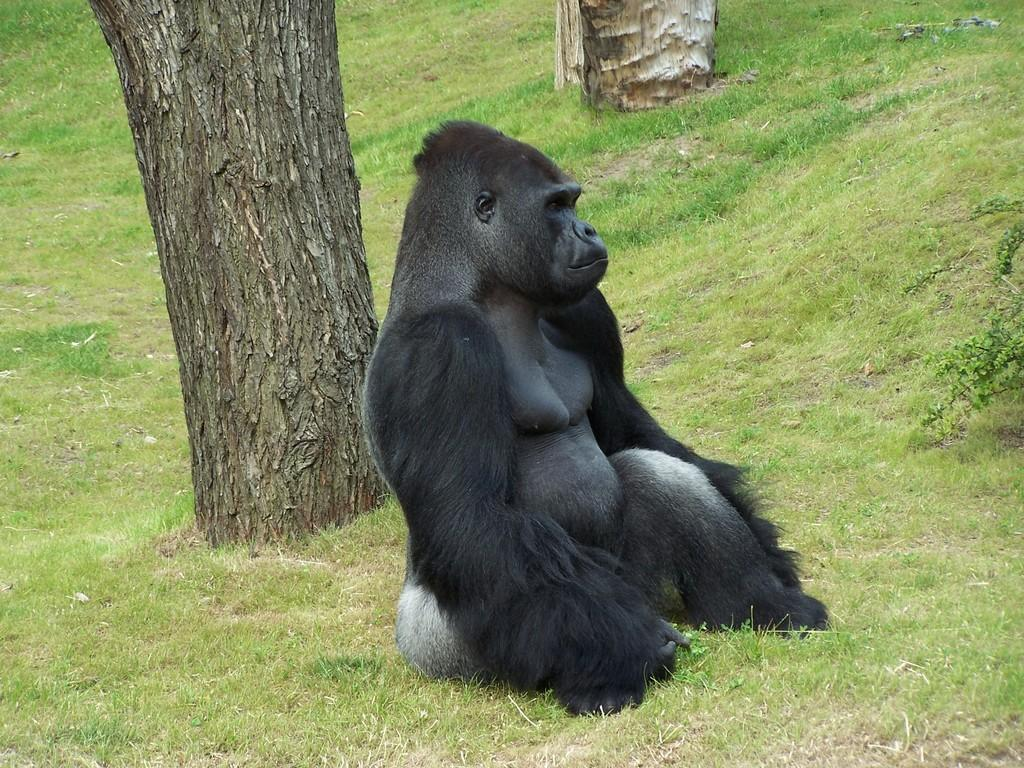What animal is the main subject of the image? There is a gorilla in the image. Where is the gorilla located? The gorilla is sitting on a grassy land. What can be seen on the left side of the image? There is a bark of a tree on the left side of the image. How many ducks are swimming in the water near the gorilla in the image? There are no ducks or water present in the image; it features a gorilla sitting on a grassy land. What type of zebra can be seen grazing on the grass near the gorilla in the image? There is no zebra present in the image; it features a gorilla sitting on a grassy land. 